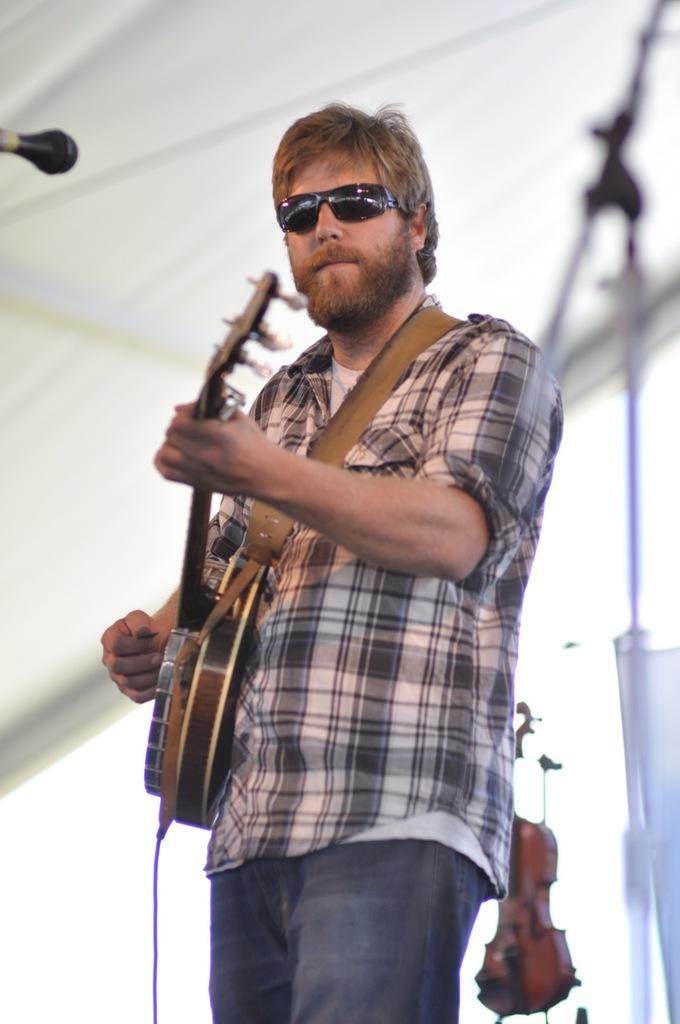What is the main subject of the image? There is a man in the image. What is the man doing in the image? The man is standing in the image. What object is the man holding in the image? The man is holding a guitar in his hand. What type of cheese is the man eating in the image? There is no cheese present in the image; the man is holding a guitar. 